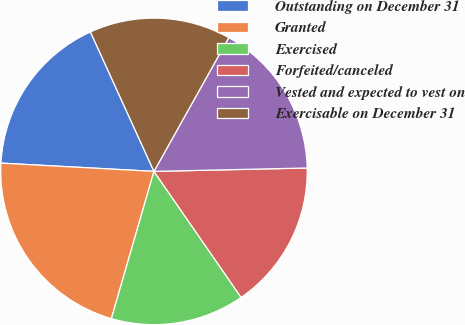Convert chart. <chart><loc_0><loc_0><loc_500><loc_500><pie_chart><fcel>Outstanding on December 31<fcel>Granted<fcel>Exercised<fcel>Forfeited/canceled<fcel>Vested and expected to vest on<fcel>Exercisable on December 31<nl><fcel>17.34%<fcel>21.38%<fcel>14.11%<fcel>15.72%<fcel>16.53%<fcel>14.92%<nl></chart> 